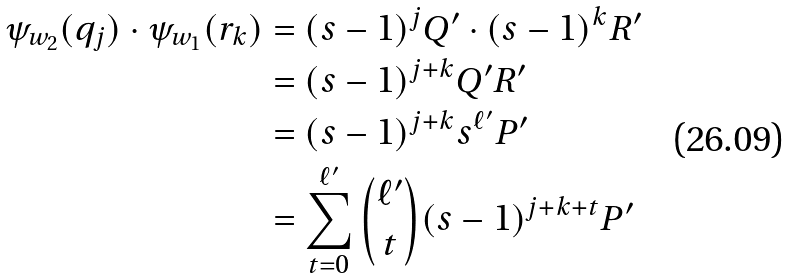Convert formula to latex. <formula><loc_0><loc_0><loc_500><loc_500>\psi _ { w _ { 2 } } ( q _ { j } ) \cdot \psi _ { w _ { 1 } } ( r _ { k } ) & = ( s - 1 ) ^ { j } Q ^ { \prime } \cdot ( s - 1 ) ^ { k } R ^ { \prime } \\ & = ( s - 1 ) ^ { j + k } Q ^ { \prime } R ^ { \prime } \\ & = ( s - 1 ) ^ { j + k } s ^ { \ell ^ { \prime } } P ^ { \prime } \\ & = \sum _ { t = 0 } ^ { \ell ^ { \prime } } \binom { \ell ^ { \prime } } { t } ( s - 1 ) ^ { j + k + t } P ^ { \prime }</formula> 